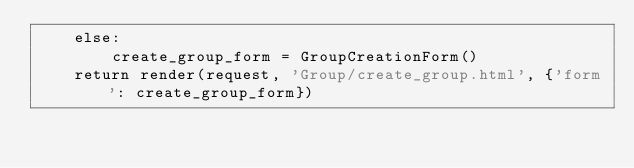<code> <loc_0><loc_0><loc_500><loc_500><_Python_>    else:
        create_group_form = GroupCreationForm()
    return render(request, 'Group/create_group.html', {'form': create_group_form})
</code> 